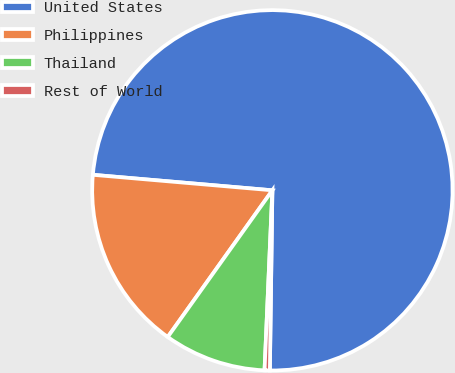<chart> <loc_0><loc_0><loc_500><loc_500><pie_chart><fcel>United States<fcel>Philippines<fcel>Thailand<fcel>Rest of World<nl><fcel>73.85%<fcel>16.51%<fcel>9.17%<fcel>0.47%<nl></chart> 